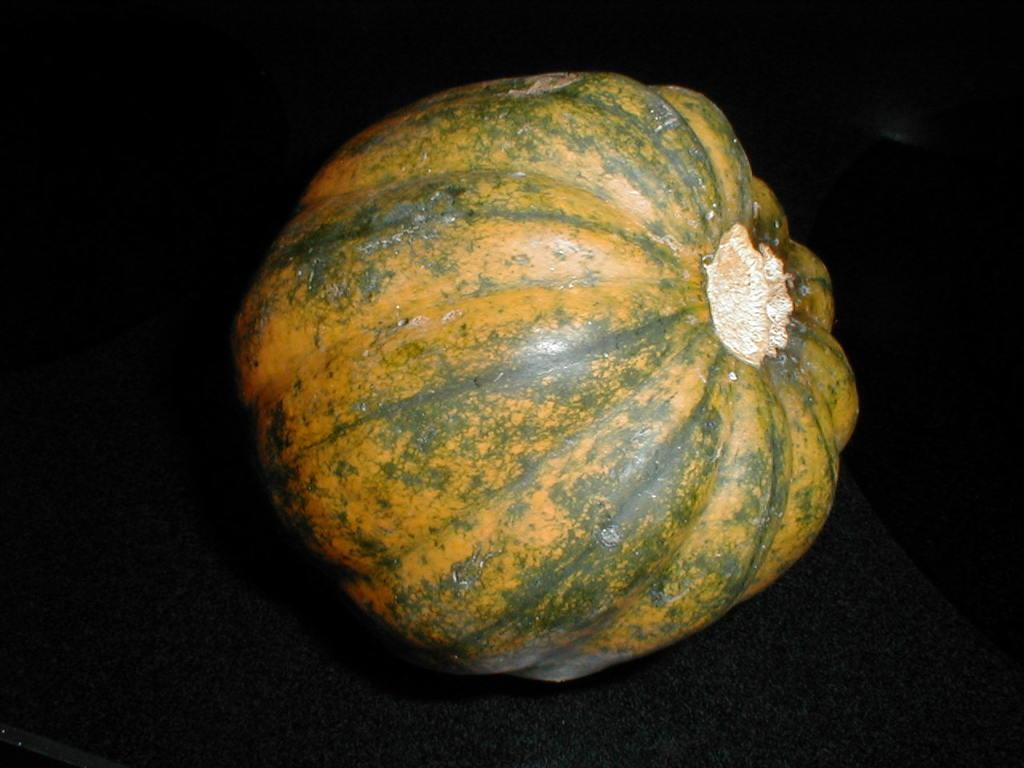What is the main object in the picture? There is a pumpkin in the picture. What color is the pumpkin? The pumpkin is yellow in color. Are there any additional details on the pumpkin? Yes, there are green lines shaded on the pumpkin. How many bikes are parked next to the pumpkin in the image? There are no bikes present in the image; it only features a pumpkin with green lines shaded on it. 